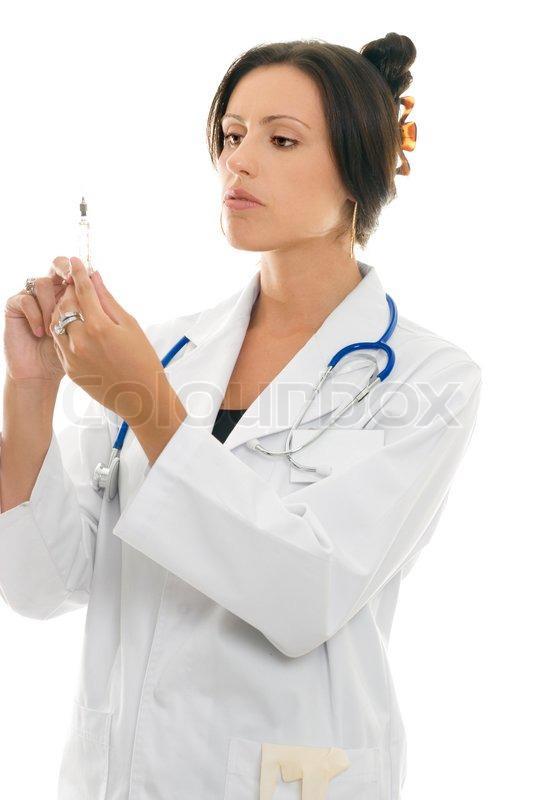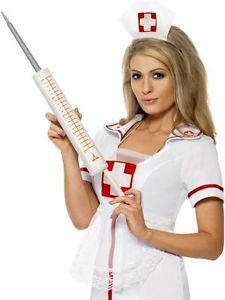The first image is the image on the left, the second image is the image on the right. Considering the images on both sides, is "There are two women holding a needle with colored liquid in it." valid? Answer yes or no. No. The first image is the image on the left, the second image is the image on the right. Considering the images on both sides, is "The liquid in at least one of the syringes is orange." valid? Answer yes or no. No. 